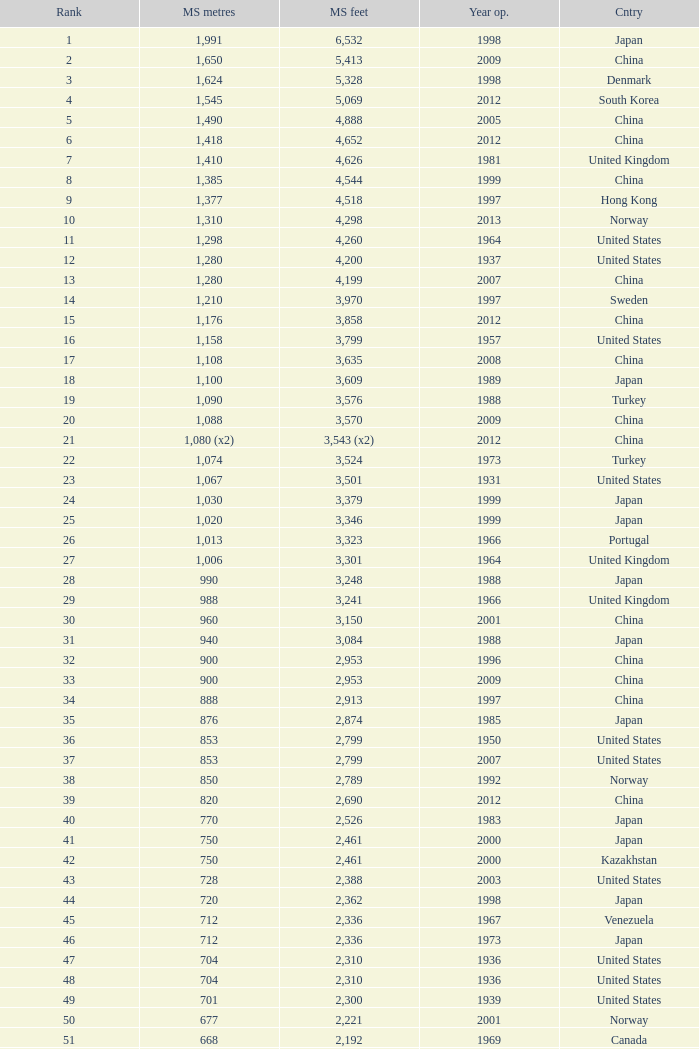What is the main span feet from opening year of 1936 in the United States with a rank greater than 47 and 421 main span metres? 1381.0. 